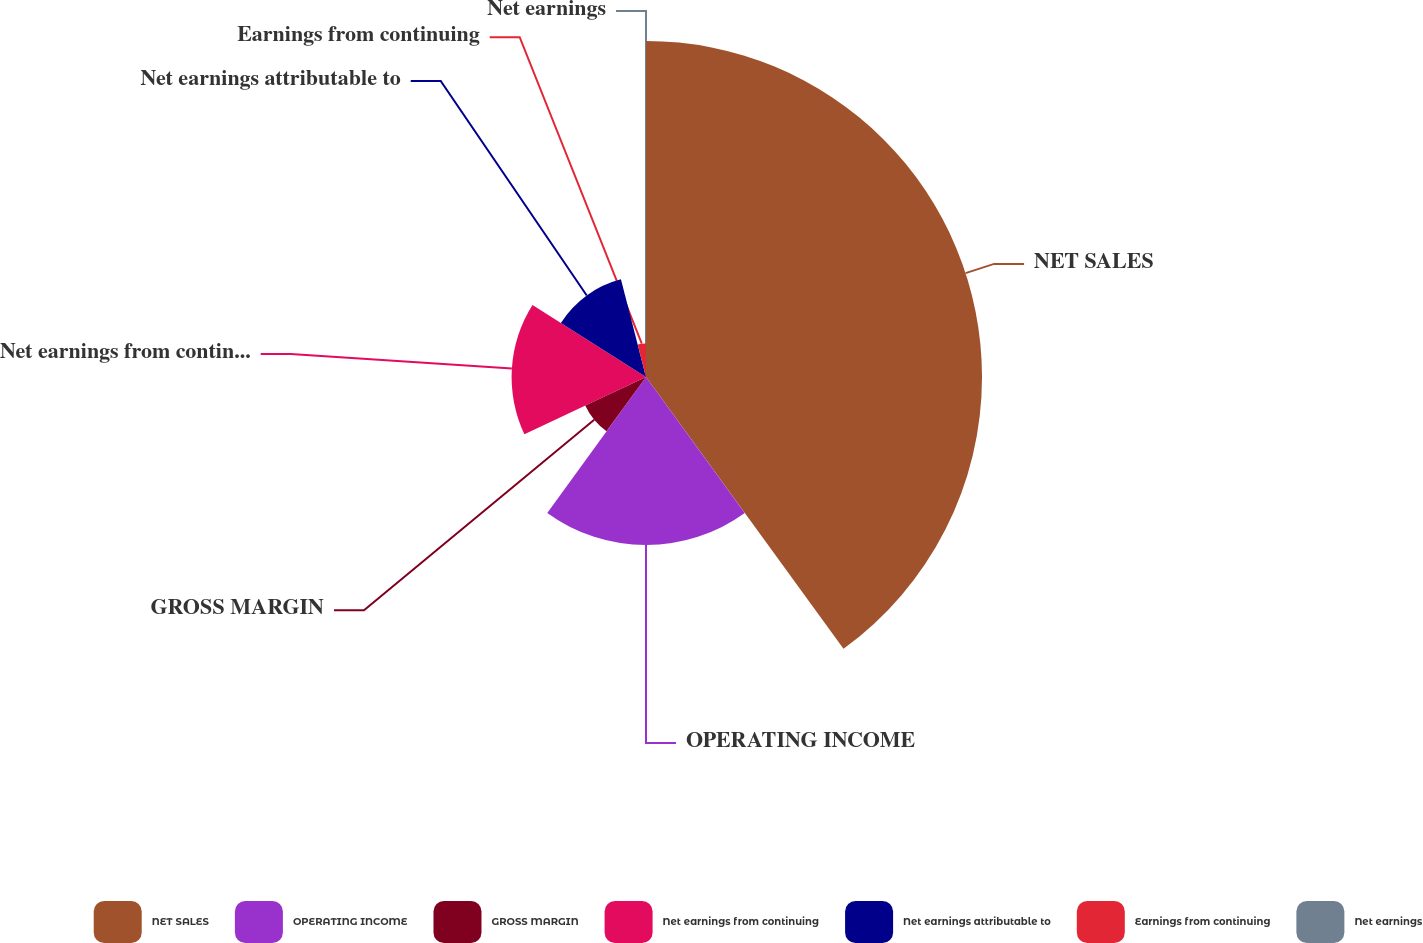Convert chart. <chart><loc_0><loc_0><loc_500><loc_500><pie_chart><fcel>NET SALES<fcel>OPERATING INCOME<fcel>GROSS MARGIN<fcel>Net earnings from continuing<fcel>Net earnings attributable to<fcel>Earnings from continuing<fcel>Net earnings<nl><fcel>40.0%<fcel>20.0%<fcel>8.0%<fcel>16.0%<fcel>12.0%<fcel>4.0%<fcel>0.0%<nl></chart> 